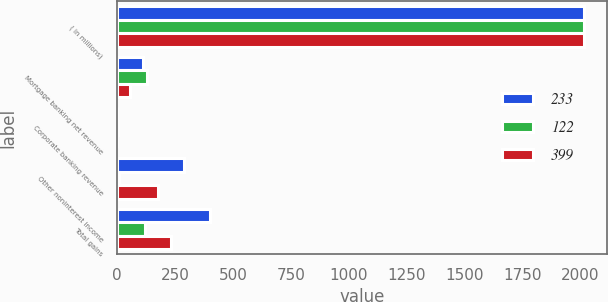<chart> <loc_0><loc_0><loc_500><loc_500><stacked_bar_chart><ecel><fcel>( in millions)<fcel>Mortgage banking net revenue<fcel>Corporate banking revenue<fcel>Other noninterest income<fcel>Total gains<nl><fcel>233<fcel>2015<fcel>110<fcel>1<fcel>288<fcel>399<nl><fcel>122<fcel>2014<fcel>127<fcel>2<fcel>7<fcel>122<nl><fcel>399<fcel>2013<fcel>57<fcel>1<fcel>175<fcel>233<nl></chart> 